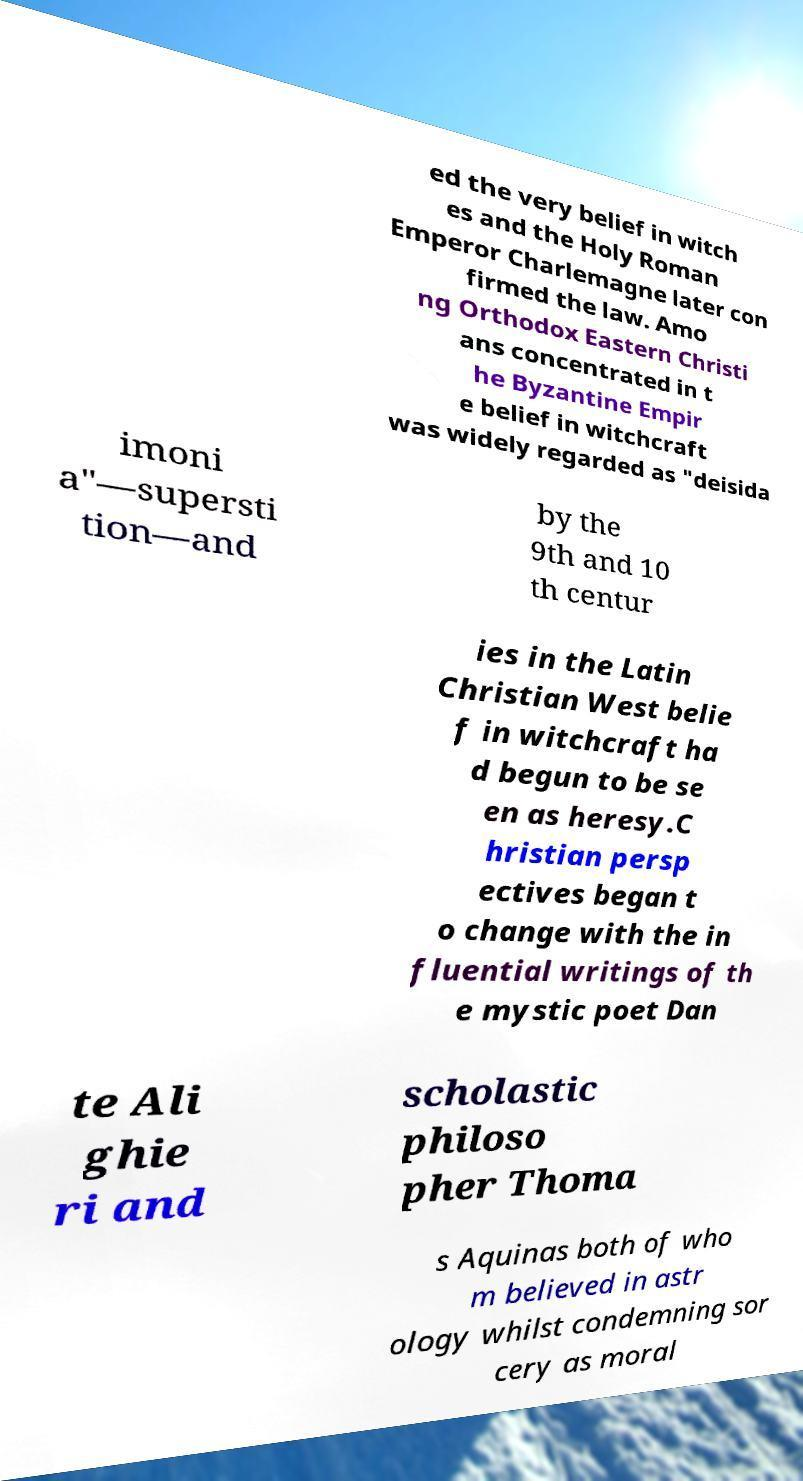Can you read and provide the text displayed in the image?This photo seems to have some interesting text. Can you extract and type it out for me? ed the very belief in witch es and the Holy Roman Emperor Charlemagne later con firmed the law. Amo ng Orthodox Eastern Christi ans concentrated in t he Byzantine Empir e belief in witchcraft was widely regarded as "deisida imoni a"—supersti tion—and by the 9th and 10 th centur ies in the Latin Christian West belie f in witchcraft ha d begun to be se en as heresy.C hristian persp ectives began t o change with the in fluential writings of th e mystic poet Dan te Ali ghie ri and scholastic philoso pher Thoma s Aquinas both of who m believed in astr ology whilst condemning sor cery as moral 